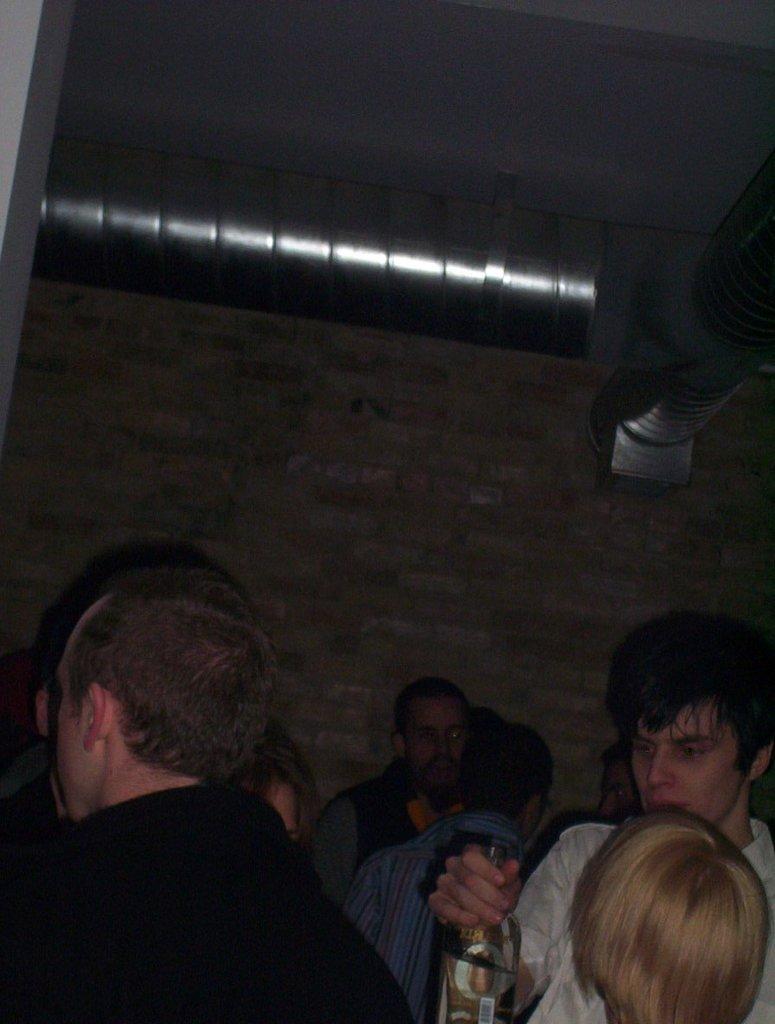Could you give a brief overview of what you see in this image? This is an image clicked in the dark and it is an inside view. At the bottom of the image I can see few people. There is a man is holding a wine bottle in the hand. At the back of these people I can see a wall to which a metal rod is attached. 